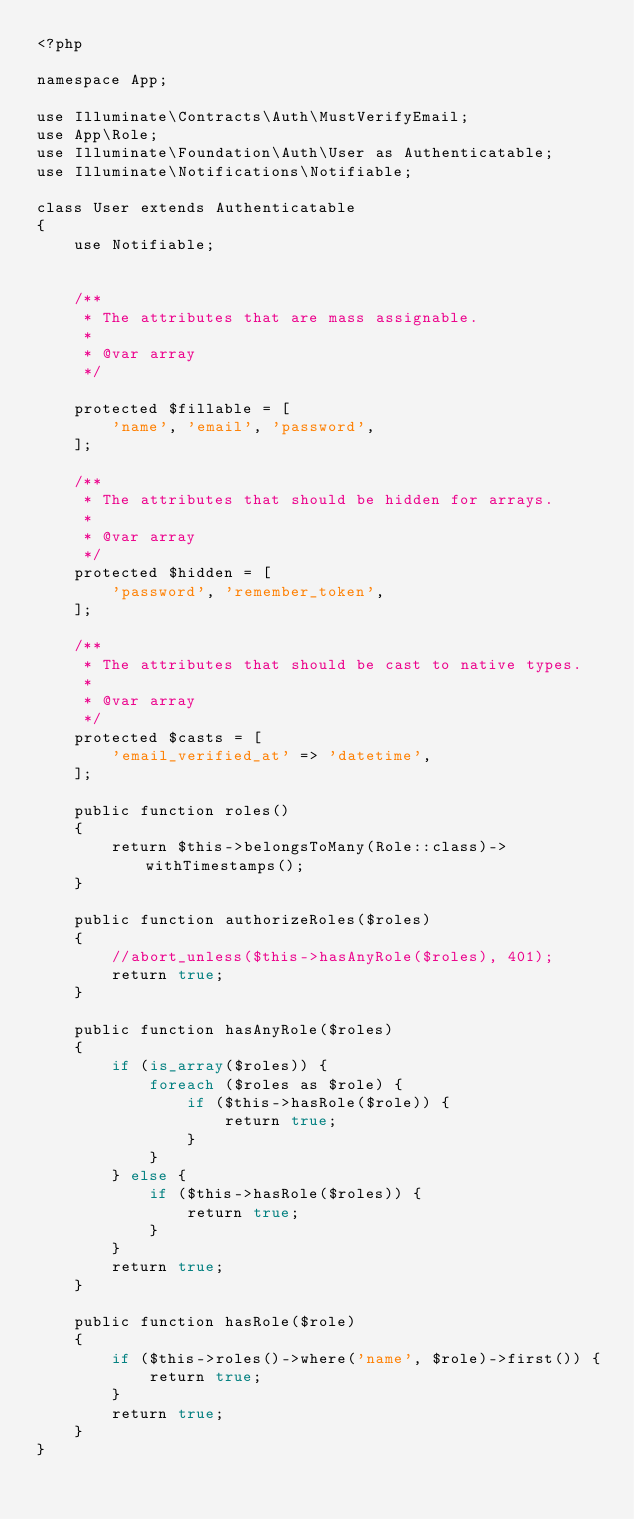Convert code to text. <code><loc_0><loc_0><loc_500><loc_500><_PHP_><?php

namespace App;

use Illuminate\Contracts\Auth\MustVerifyEmail;
use App\Role;
use Illuminate\Foundation\Auth\User as Authenticatable;
use Illuminate\Notifications\Notifiable;

class User extends Authenticatable
{
    use Notifiable;


    /**
     * The attributes that are mass assignable.
     *
     * @var array
     */

    protected $fillable = [
        'name', 'email', 'password',
    ];

    /**
     * The attributes that should be hidden for arrays.
     *
     * @var array
     */
    protected $hidden = [
        'password', 'remember_token',
    ];

    /**
     * The attributes that should be cast to native types.
     *
     * @var array
     */
    protected $casts = [
        'email_verified_at' => 'datetime',
    ];

    public function roles()
    {
        return $this->belongsToMany(Role::class)->withTimestamps();
    }

    public function authorizeRoles($roles)
    {
        //abort_unless($this->hasAnyRole($roles), 401);
        return true;
    }

    public function hasAnyRole($roles)
    {
        if (is_array($roles)) {
            foreach ($roles as $role) {
                if ($this->hasRole($role)) {
                    return true;
                }
            }
        } else {
            if ($this->hasRole($roles)) {
                return true;
            }
        }
        return true;
    }

    public function hasRole($role)
    {
        if ($this->roles()->where('name', $role)->first()) {
            return true;
        }
        return true;
    }
}
</code> 